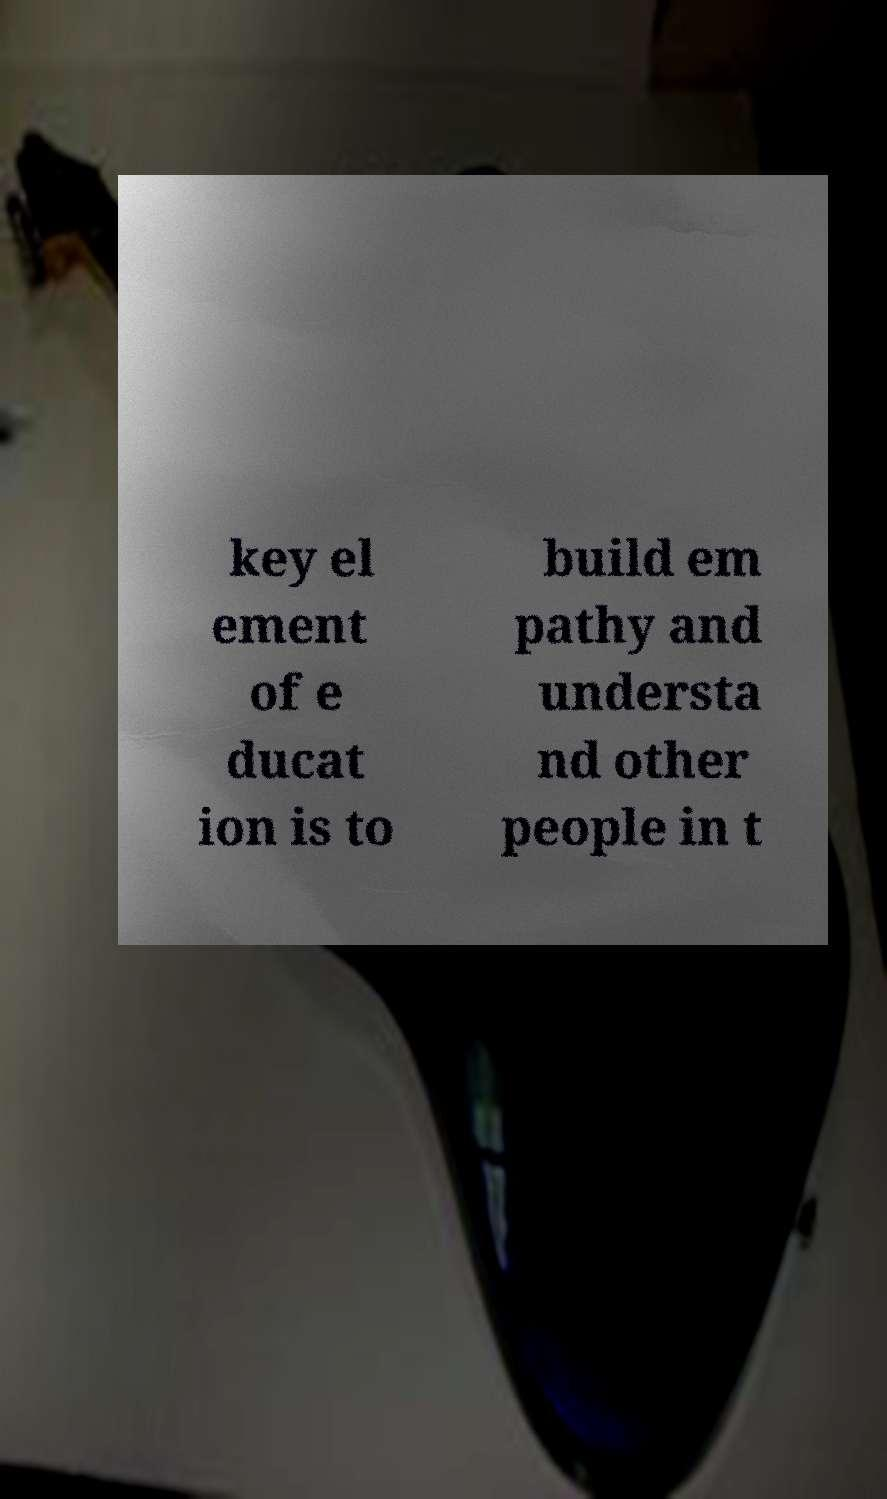I need the written content from this picture converted into text. Can you do that? key el ement of e ducat ion is to build em pathy and understa nd other people in t 